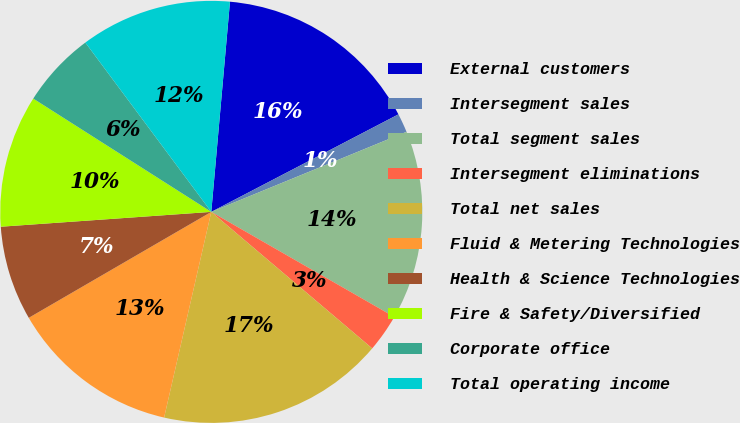<chart> <loc_0><loc_0><loc_500><loc_500><pie_chart><fcel>External customers<fcel>Intersegment sales<fcel>Total segment sales<fcel>Intersegment eliminations<fcel>Total net sales<fcel>Fluid & Metering Technologies<fcel>Health & Science Technologies<fcel>Fire & Safety/Diversified<fcel>Corporate office<fcel>Total operating income<nl><fcel>15.94%<fcel>1.45%<fcel>14.49%<fcel>2.9%<fcel>17.39%<fcel>13.04%<fcel>7.25%<fcel>10.14%<fcel>5.8%<fcel>11.59%<nl></chart> 